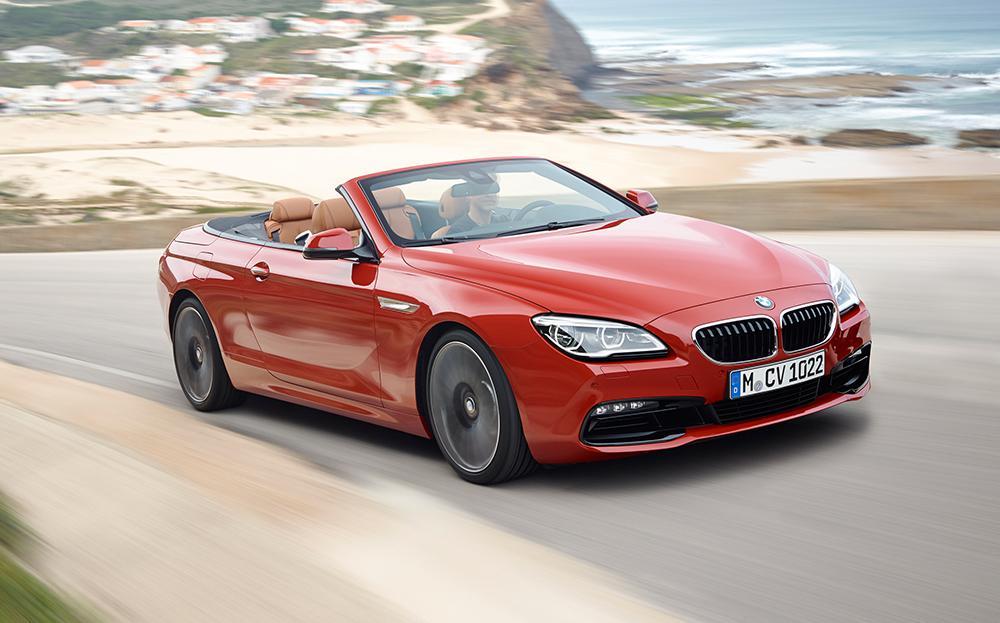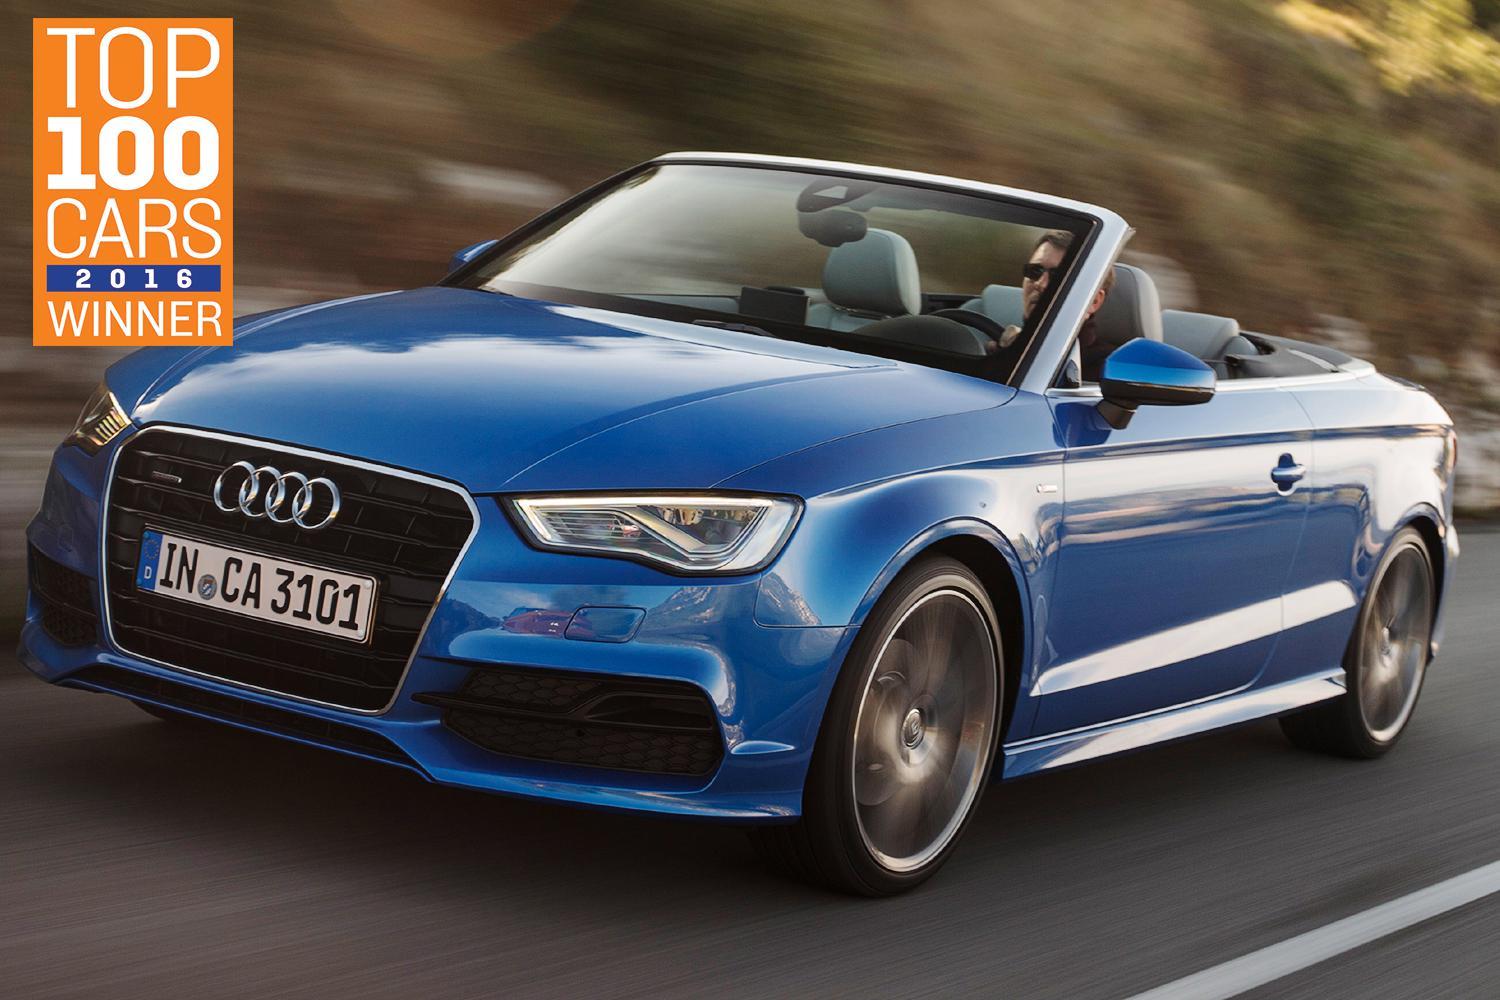The first image is the image on the left, the second image is the image on the right. Assess this claim about the two images: "The left image contains a red convertible vehicle.". Correct or not? Answer yes or no. Yes. The first image is the image on the left, the second image is the image on the right. Examine the images to the left and right. Is the description "The left image features a red convertible car with its top down" accurate? Answer yes or no. Yes. 